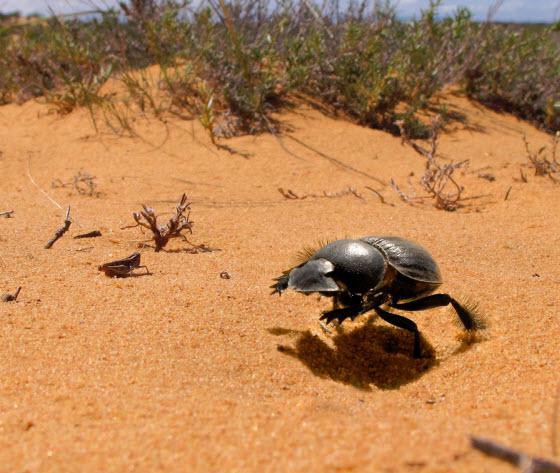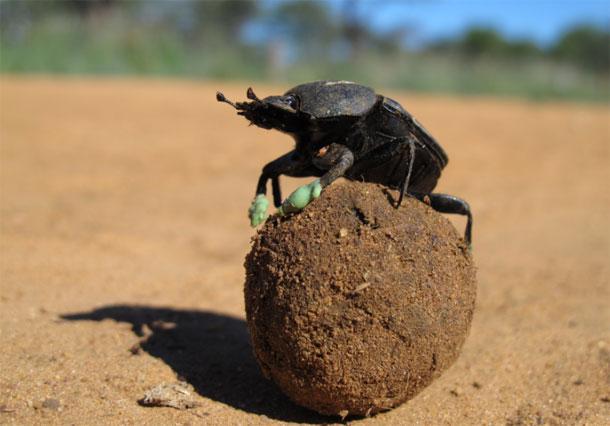The first image is the image on the left, the second image is the image on the right. Considering the images on both sides, is "There is one beetle that is not touching a ball of dung." valid? Answer yes or no. Yes. 